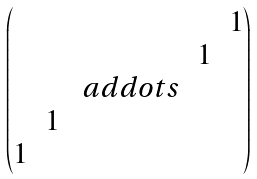Convert formula to latex. <formula><loc_0><loc_0><loc_500><loc_500>\begin{pmatrix} & & & & 1 \\ & & & 1 \\ & & \ a d d o t s \\ & 1 \\ 1 \end{pmatrix}</formula> 